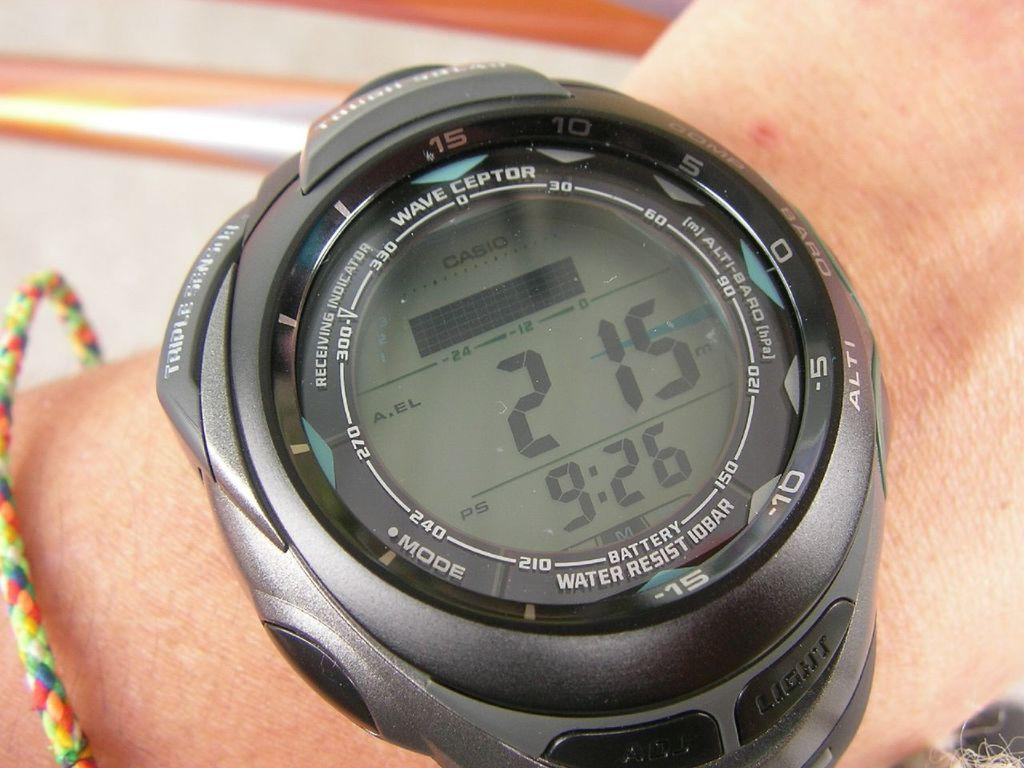<image>
Give a short and clear explanation of the subsequent image. A black watch shows the time at "9:26." 